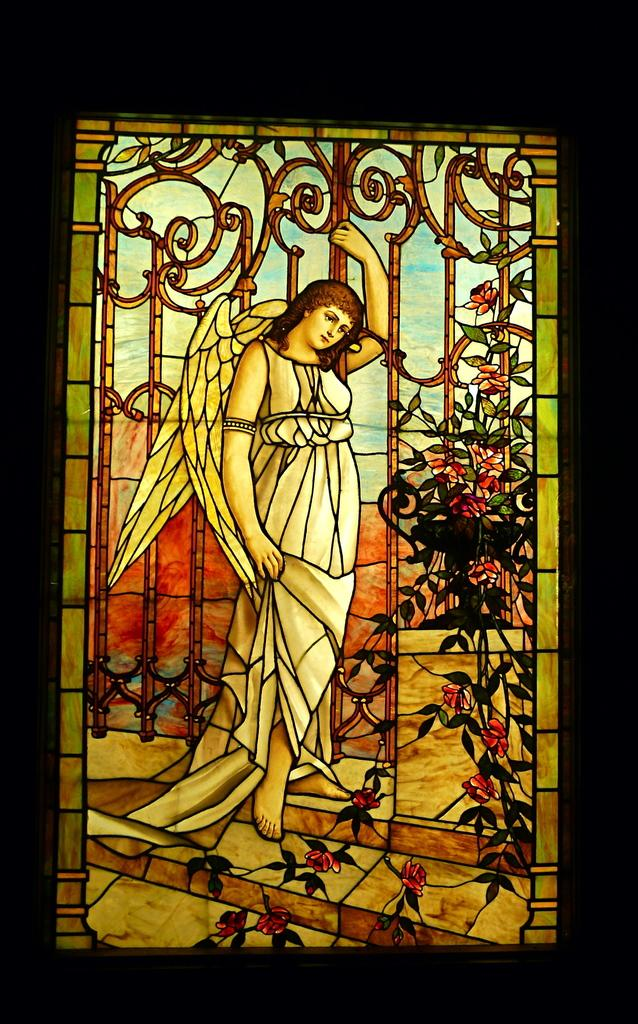What is the main subject of the image? The main subject of the image is a painting frame. What is depicted within the painting frame? There is a picture of a woman in the frame. How would you describe the overall appearance of the image? The background of the image is dark. How many chairs are visible in the image? There are no chairs present in the image. What type of sugar is being used to sweeten the painting in the image? There is no sugar present in the image, as it features a painting frame with a picture of a woman. 